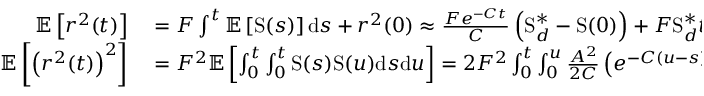<formula> <loc_0><loc_0><loc_500><loc_500>\begin{array} { r l } { \mathbb { E } \left [ r ^ { 2 } ( t ) \right ] } & = F \int ^ { t } \mathbb { E } \left [ S ( s ) \right ] d s + r ^ { 2 } ( 0 ) \approx \frac { F e ^ { - C t } } { C } \left ( S _ { d } ^ { \ast } - S ( 0 ) \right ) + F S _ { d } ^ { \ast } t + r ^ { 2 } ( 0 ) } \\ { \mathbb { E } \left [ \left ( r ^ { 2 } ( t ) \right ) ^ { 2 } \right ] } & = F ^ { 2 } \mathbb { E } \left [ \int _ { 0 } ^ { t } \int _ { 0 } ^ { t } S ( s ) S ( u ) d s d u \right ] = 2 F ^ { 2 } \int _ { 0 } ^ { t } \int _ { 0 } ^ { u } \frac { A ^ { 2 } } { 2 C } \left ( e ^ { - C ( u - s ) } - e ^ { - C ( u + s ) } \right ) d s d u } \end{array}</formula> 